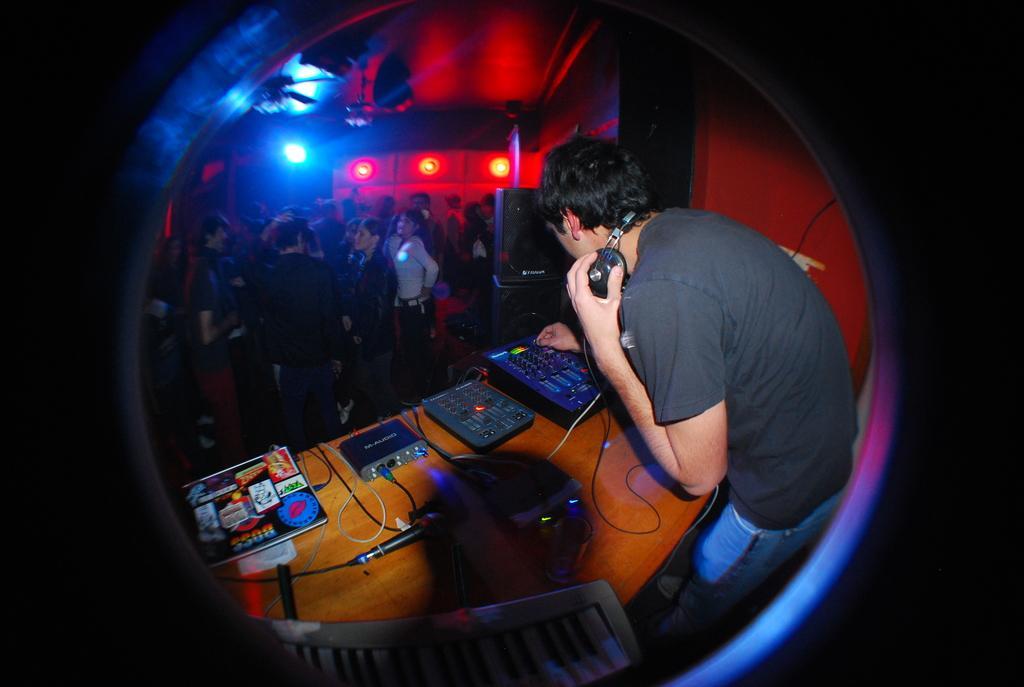Can you describe this image briefly? In this image we can see a person wore headset. There is a table. On the table we can see devices, cables, and a mike. Here we can see a chair, people, speakers, and lights. 